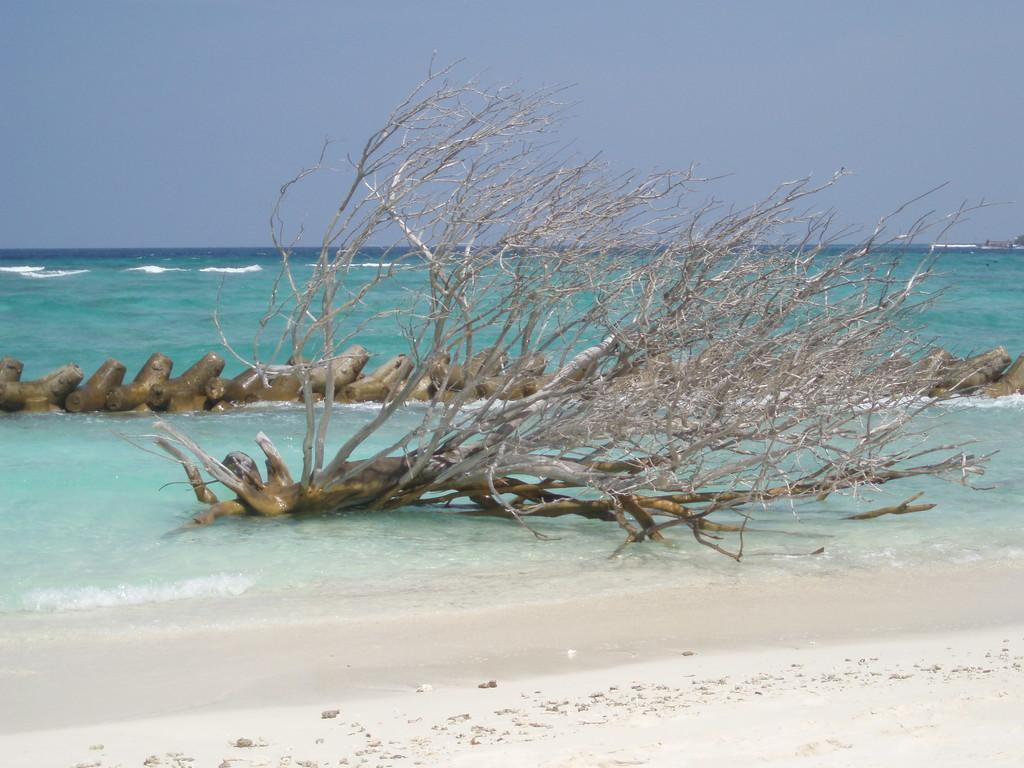How would you summarize this image in a sentence or two? In this picture we can see a tree in water. There is a wooden log in water from left to right. Waves are visible in water. 